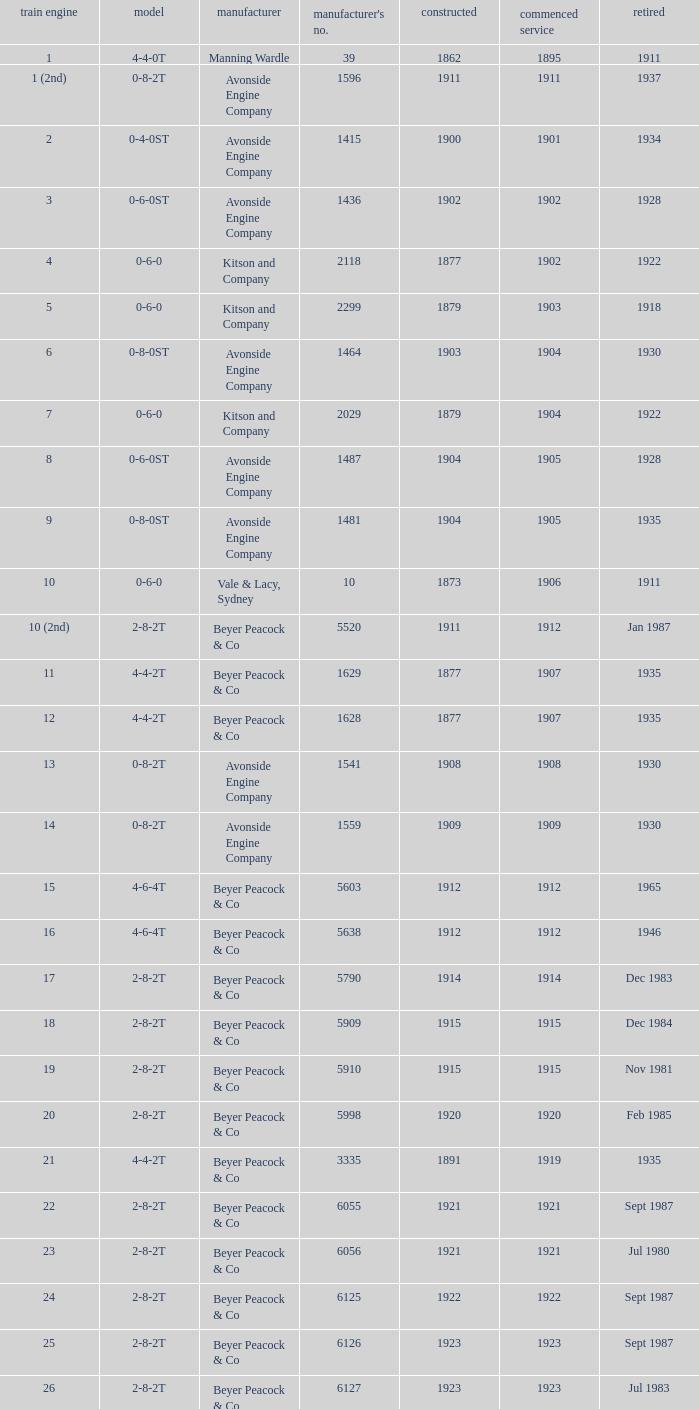How many years entered service when there were 13 locomotives? 1.0. 